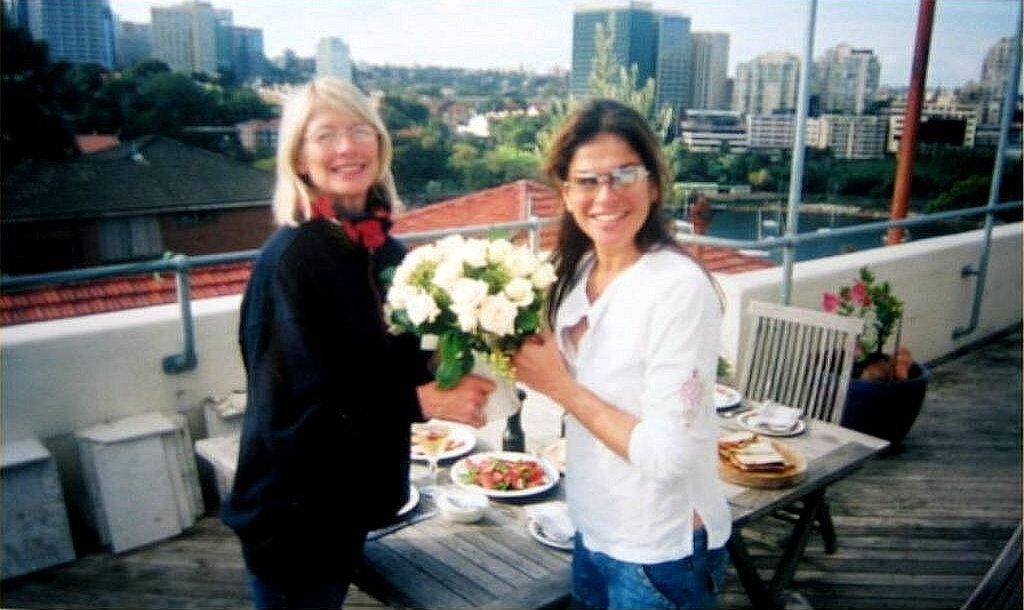Can you describe this image briefly? This picture we can see two women from the left we can see a girl receiving the white flower bookey from the other women wearing white top and blue jean, behind there is dining table on which food and tea cup are placed, Extreme behind we can see good view of the building , tree and clear sky. 